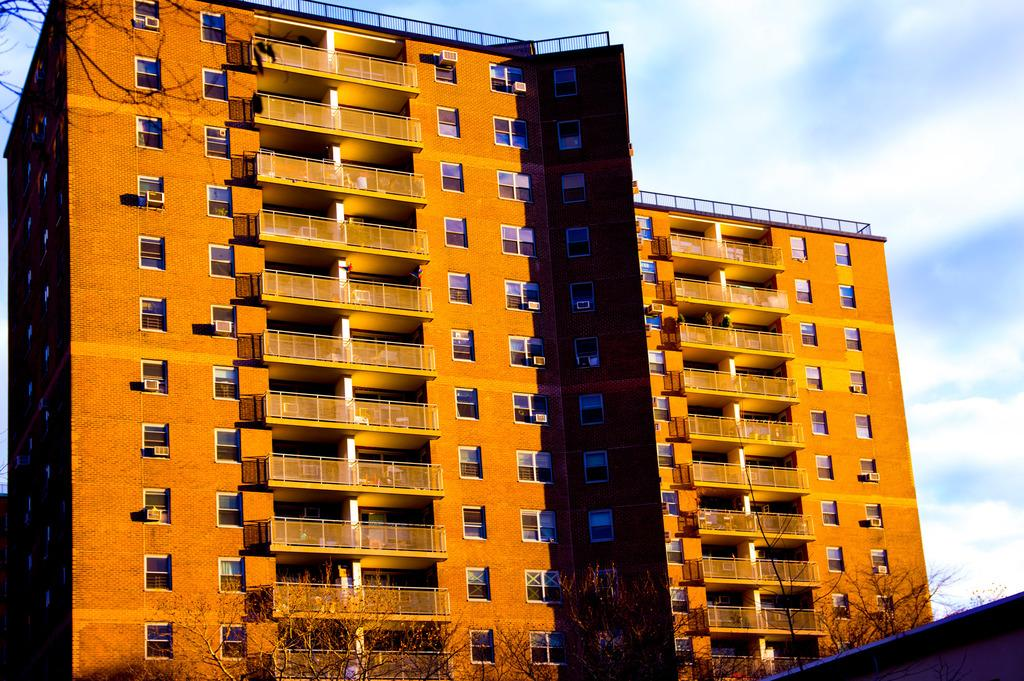What structures can be seen in the image? There are buildings in the image. What type of vegetation is in front of the buildings? There are trees in front of the buildings. What part of the natural environment is visible in the image? The sky is visible in the background of the image. What type of pest can be seen crawling on the buildings in the image? There is no pest visible on the buildings in the image. How many pigs are present in the image? There are no pigs present in the image. 